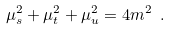<formula> <loc_0><loc_0><loc_500><loc_500>\mu ^ { 2 } _ { s } + \mu ^ { 2 } _ { t } + \mu ^ { 2 } _ { u } = 4 m ^ { 2 } \ .</formula> 